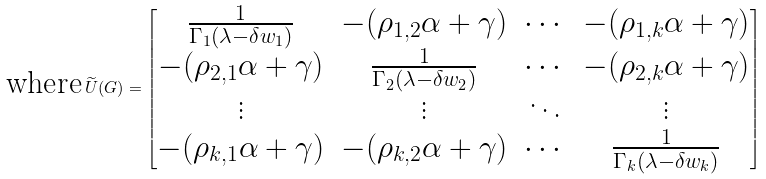Convert formula to latex. <formula><loc_0><loc_0><loc_500><loc_500>\text {where} \, \widetilde { U } ( G ) = \begin{bmatrix} \frac { 1 } { \Gamma _ { 1 } ( \lambda - \delta w _ { 1 } ) } & - ( \rho _ { 1 , 2 } \alpha + \gamma ) & \cdots & - ( \rho _ { 1 , k } \alpha + \gamma ) \\ - ( \rho _ { 2 , 1 } \alpha + \gamma ) & \frac { 1 } { \Gamma _ { 2 } ( \lambda - \delta w _ { 2 } ) } & \cdots & - ( \rho _ { 2 , k } \alpha + \gamma ) \\ \vdots & \vdots & \ddots & \vdots \\ - ( \rho _ { k , 1 } \alpha + \gamma ) & - ( \rho _ { k , 2 } \alpha + \gamma ) & \cdots & \frac { 1 } { \Gamma _ { k } ( \lambda - \delta w _ { k } ) } \end{bmatrix}</formula> 